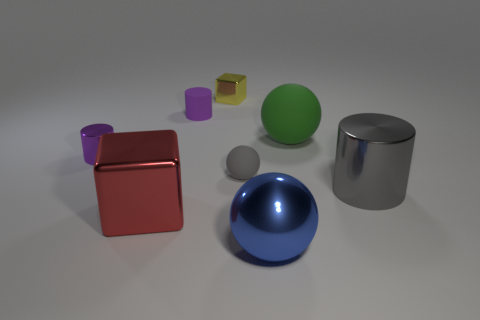The large object that is behind the red block and on the left side of the big gray thing is made of what material?
Keep it short and to the point. Rubber. What material is the big sphere that is behind the shiny cylinder behind the big gray metal cylinder?
Give a very brief answer. Rubber. What number of other objects are the same shape as the small gray thing?
Give a very brief answer. 2. Is there a matte thing that has the same color as the big shiny cylinder?
Provide a short and direct response. Yes. How many objects are either big objects that are to the right of the rubber cylinder or big things on the right side of the yellow metal block?
Keep it short and to the point. 3. There is a rubber thing that is right of the large blue metal thing; are there any small metal blocks that are to the left of it?
Your answer should be compact. Yes. What shape is the gray object that is the same size as the purple matte cylinder?
Keep it short and to the point. Sphere. How many objects are big things in front of the green rubber ball or big blue matte spheres?
Offer a terse response. 3. How many other objects are the same material as the big green sphere?
Provide a short and direct response. 2. The tiny rubber thing that is the same color as the small shiny cylinder is what shape?
Keep it short and to the point. Cylinder. 